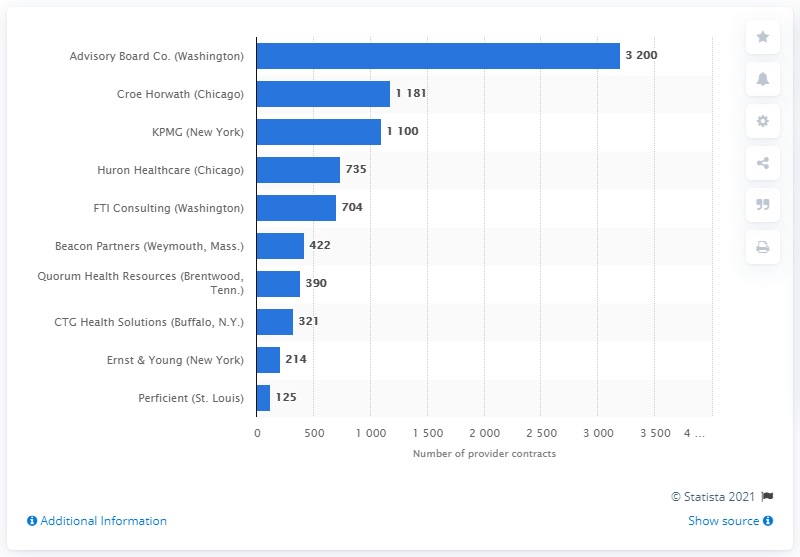Mention a couple of crucial points in this snapshot. In 2013, Ernst & Young held 214 provider contracts. 